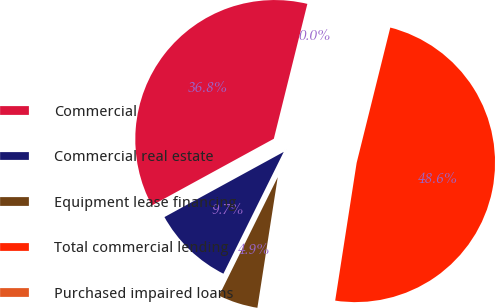Convert chart. <chart><loc_0><loc_0><loc_500><loc_500><pie_chart><fcel>Commercial<fcel>Commercial real estate<fcel>Equipment lease financing<fcel>Total commercial lending<fcel>Purchased impaired loans<nl><fcel>36.84%<fcel>9.72%<fcel>4.86%<fcel>48.58%<fcel>0.0%<nl></chart> 